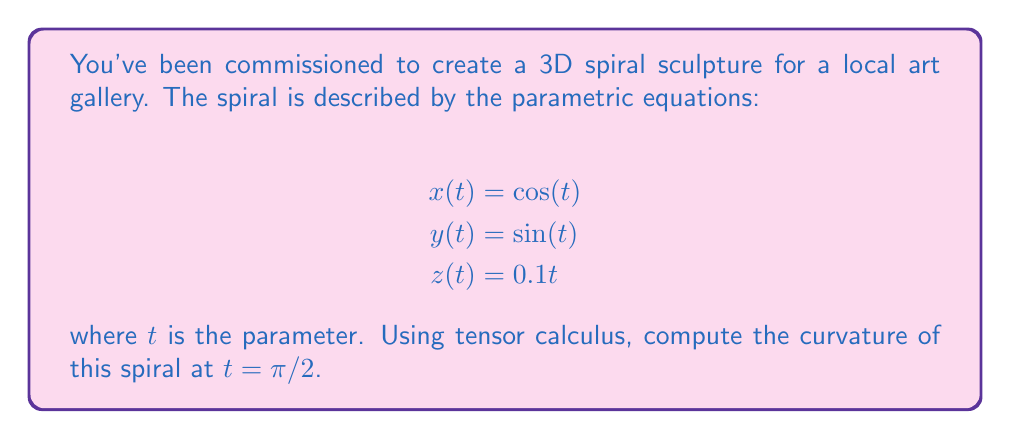Show me your answer to this math problem. To find the curvature of the 3D spiral, we'll follow these steps:

1) First, we need to find the velocity vector $\mathbf{v}(t)$. This is the first derivative of the position vector:

   $$\mathbf{v}(t) = \frac{d}{dt}(x(t), y(t), z(t)) = (-\sin(t), \cos(t), 0.1)$$

2) Next, we calculate the acceleration vector $\mathbf{a}(t)$, which is the second derivative:

   $$\mathbf{a}(t) = \frac{d}{dt}\mathbf{v}(t) = (-\cos(t), -\sin(t), 0)$$

3) The curvature $\kappa$ is given by the formula:

   $$\kappa = \frac{|\mathbf{v} \times \mathbf{a}|}{|\mathbf{v}|^3}$$

4) Let's calculate the cross product $\mathbf{v} \times \mathbf{a}$:

   $$\mathbf{v} \times \mathbf{a} = \begin{vmatrix} 
   \mathbf{i} & \mathbf{j} & \mathbf{k} \\
   -\sin(t) & \cos(t) & 0.1 \\
   -\cos(t) & -\sin(t) & 0
   \end{vmatrix}$$

   $$= (0.1\sin(t), -0.1\cos(t), \sin^2(t) + \cos^2(t)) = (0.1\sin(t), -0.1\cos(t), 1)$$

5) The magnitude of this cross product is:

   $$|\mathbf{v} \times \mathbf{a}| = \sqrt{0.01\sin^2(t) + 0.01\cos^2(t) + 1} = \sqrt{1.01}$$

6) The magnitude of the velocity vector is:

   $$|\mathbf{v}| = \sqrt{\sin^2(t) + \cos^2(t) + 0.01} = \sqrt{1.01}$$

7) Now we can compute the curvature:

   $$\kappa = \frac{\sqrt{1.01}}{(\sqrt{1.01})^3} = \frac{1}{\sqrt{1.01}}$$

8) This result is independent of $t$, so it's the same for all points on the spiral, including $t = \pi/2$.
Answer: $\kappa = \frac{1}{\sqrt{1.01}} \approx 0.9950$ 